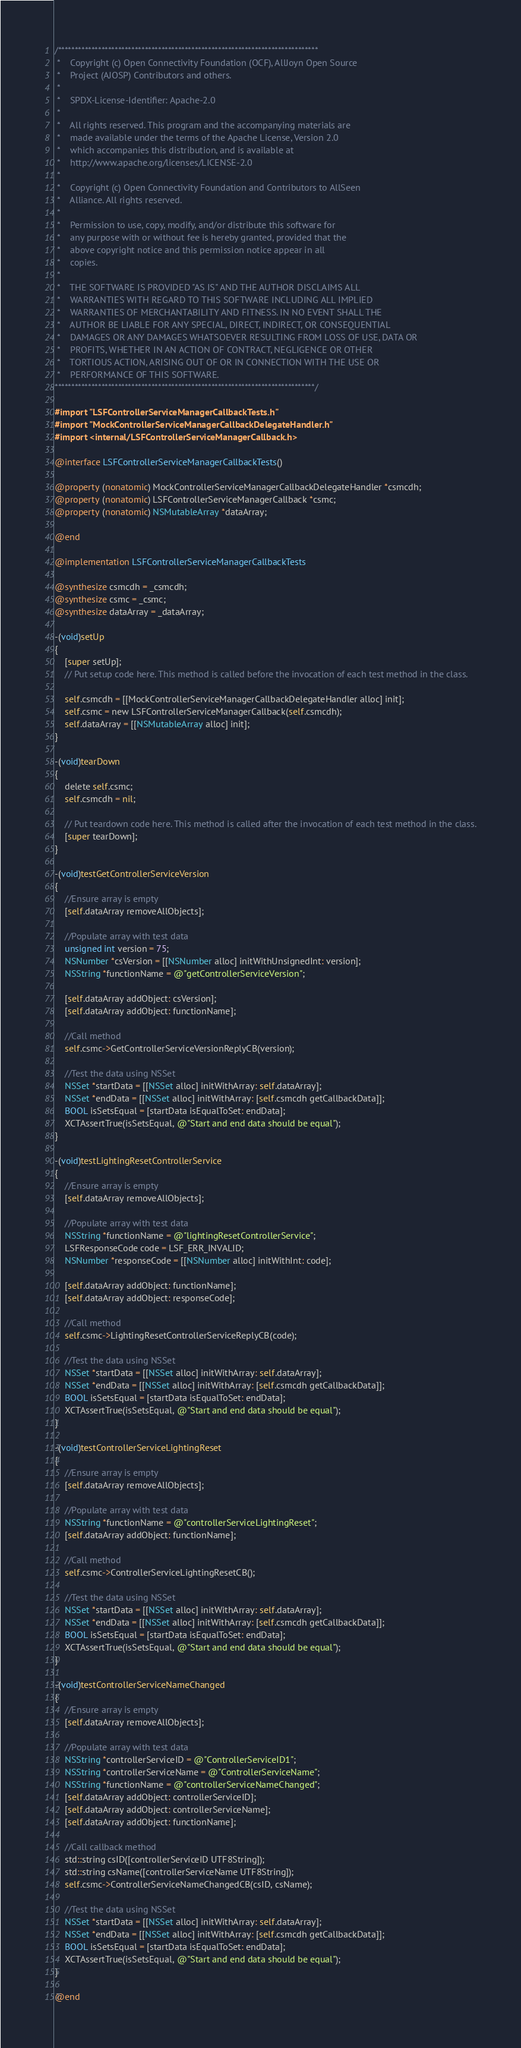Convert code to text. <code><loc_0><loc_0><loc_500><loc_500><_ObjectiveC_>/******************************************************************************
 *    Copyright (c) Open Connectivity Foundation (OCF), AllJoyn Open Source
 *    Project (AJOSP) Contributors and others.
 *    
 *    SPDX-License-Identifier: Apache-2.0
 *    
 *    All rights reserved. This program and the accompanying materials are
 *    made available under the terms of the Apache License, Version 2.0
 *    which accompanies this distribution, and is available at
 *    http://www.apache.org/licenses/LICENSE-2.0
 *    
 *    Copyright (c) Open Connectivity Foundation and Contributors to AllSeen
 *    Alliance. All rights reserved.
 *    
 *    Permission to use, copy, modify, and/or distribute this software for
 *    any purpose with or without fee is hereby granted, provided that the
 *    above copyright notice and this permission notice appear in all
 *    copies.
 *    
 *    THE SOFTWARE IS PROVIDED "AS IS" AND THE AUTHOR DISCLAIMS ALL
 *    WARRANTIES WITH REGARD TO THIS SOFTWARE INCLUDING ALL IMPLIED
 *    WARRANTIES OF MERCHANTABILITY AND FITNESS. IN NO EVENT SHALL THE
 *    AUTHOR BE LIABLE FOR ANY SPECIAL, DIRECT, INDIRECT, OR CONSEQUENTIAL
 *    DAMAGES OR ANY DAMAGES WHATSOEVER RESULTING FROM LOSS OF USE, DATA OR
 *    PROFITS, WHETHER IN AN ACTION OF CONTRACT, NEGLIGENCE OR OTHER
 *    TORTIOUS ACTION, ARISING OUT OF OR IN CONNECTION WITH THE USE OR
 *    PERFORMANCE OF THIS SOFTWARE.
******************************************************************************/

#import "LSFControllerServiceManagerCallbackTests.h"
#import "MockControllerServiceManagerCallbackDelegateHandler.h"
#import <internal/LSFControllerServiceManagerCallback.h>

@interface LSFControllerServiceManagerCallbackTests()

@property (nonatomic) MockControllerServiceManagerCallbackDelegateHandler *csmcdh;
@property (nonatomic) LSFControllerServiceManagerCallback *csmc;
@property (nonatomic) NSMutableArray *dataArray;

@end

@implementation LSFControllerServiceManagerCallbackTests

@synthesize csmcdh = _csmcdh;
@synthesize csmc = _csmc;
@synthesize dataArray = _dataArray;

-(void)setUp
{
    [super setUp];
    // Put setup code here. This method is called before the invocation of each test method in the class.
    
    self.csmcdh = [[MockControllerServiceManagerCallbackDelegateHandler alloc] init];
    self.csmc = new LSFControllerServiceManagerCallback(self.csmcdh);
    self.dataArray = [[NSMutableArray alloc] init];
}

-(void)tearDown
{
    delete self.csmc;
    self.csmcdh = nil;
    
    // Put teardown code here. This method is called after the invocation of each test method in the class.
    [super tearDown];
}

-(void)testGetControllerServiceVersion
{
    //Ensure array is empty
    [self.dataArray removeAllObjects];
    
    //Populate array with test data
    unsigned int version = 75;
    NSNumber *csVersion = [[NSNumber alloc] initWithUnsignedInt: version];
    NSString *functionName = @"getControllerServiceVersion";
    
    [self.dataArray addObject: csVersion];
    [self.dataArray addObject: functionName];
    
    //Call method
    self.csmc->GetControllerServiceVersionReplyCB(version);
    
    //Test the data using NSSet
    NSSet *startData = [[NSSet alloc] initWithArray: self.dataArray];
    NSSet *endData = [[NSSet alloc] initWithArray: [self.csmcdh getCallbackData]];
    BOOL isSetsEqual = [startData isEqualToSet: endData];
    XCTAssertTrue(isSetsEqual, @"Start and end data should be equal");
}

-(void)testLightingResetControllerService
{
    //Ensure array is empty
    [self.dataArray removeAllObjects];
    
    //Populate array with test data
    NSString *functionName = @"lightingResetControllerService";
    LSFResponseCode code = LSF_ERR_INVALID;
    NSNumber *responseCode = [[NSNumber alloc] initWithInt: code];
    
    [self.dataArray addObject: functionName];
    [self.dataArray addObject: responseCode];
    
    //Call method
    self.csmc->LightingResetControllerServiceReplyCB(code);
    
    //Test the data using NSSet
    NSSet *startData = [[NSSet alloc] initWithArray: self.dataArray];
    NSSet *endData = [[NSSet alloc] initWithArray: [self.csmcdh getCallbackData]];
    BOOL isSetsEqual = [startData isEqualToSet: endData];
    XCTAssertTrue(isSetsEqual, @"Start and end data should be equal");
}

-(void)testControllerServiceLightingReset
{
    //Ensure array is empty
    [self.dataArray removeAllObjects];
    
    //Populate array with test data
    NSString *functionName = @"controllerServiceLightingReset";
    [self.dataArray addObject: functionName];
    
    //Call method
    self.csmc->ControllerServiceLightingResetCB();
    
    //Test the data using NSSet
    NSSet *startData = [[NSSet alloc] initWithArray: self.dataArray];
    NSSet *endData = [[NSSet alloc] initWithArray: [self.csmcdh getCallbackData]];
    BOOL isSetsEqual = [startData isEqualToSet: endData];
    XCTAssertTrue(isSetsEqual, @"Start and end data should be equal");
}

-(void)testControllerServiceNameChanged
{
    //Ensure array is empty
    [self.dataArray removeAllObjects];
    
    //Populate array with test data
    NSString *controllerServiceID = @"ControllerServiceID1";
    NSString *controllerServiceName = @"ControllerServiceName";
    NSString *functionName = @"controllerServiceNameChanged";
    [self.dataArray addObject: controllerServiceID];
    [self.dataArray addObject: controllerServiceName];
    [self.dataArray addObject: functionName];

    //Call callback method
    std::string csID([controllerServiceID UTF8String]);
    std::string csName([controllerServiceName UTF8String]);
    self.csmc->ControllerServiceNameChangedCB(csID, csName);
    
    //Test the data using NSSet
    NSSet *startData = [[NSSet alloc] initWithArray: self.dataArray];
    NSSet *endData = [[NSSet alloc] initWithArray: [self.csmcdh getCallbackData]];
    BOOL isSetsEqual = [startData isEqualToSet: endData];
    XCTAssertTrue(isSetsEqual, @"Start and end data should be equal");
}

@end</code> 